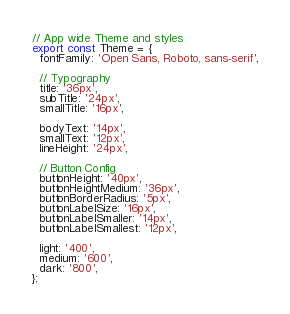<code> <loc_0><loc_0><loc_500><loc_500><_JavaScript_>// App wide Theme and styles
export const Theme = {
  fontFamily: 'Open Sans, Roboto, sans-serif',

  // Typography
  title: '36px',
  subTitle: '24px',
  smallTitle: '16px',

  bodyText: '14px',
  smallText: '12px',
  lineHeight: '24px',

  // Button Config
  buttonHeight: '40px',
  buttonHeightMedium: '36px',
  buttonBorderRadius: '5px',
  buttonLabelSize: '16px',
  buttonLabelSmaller: '14px',
  buttonLabelSmallest: '12px',

  light: '400',
  medium: '600',
  dark: '800',
};
</code> 